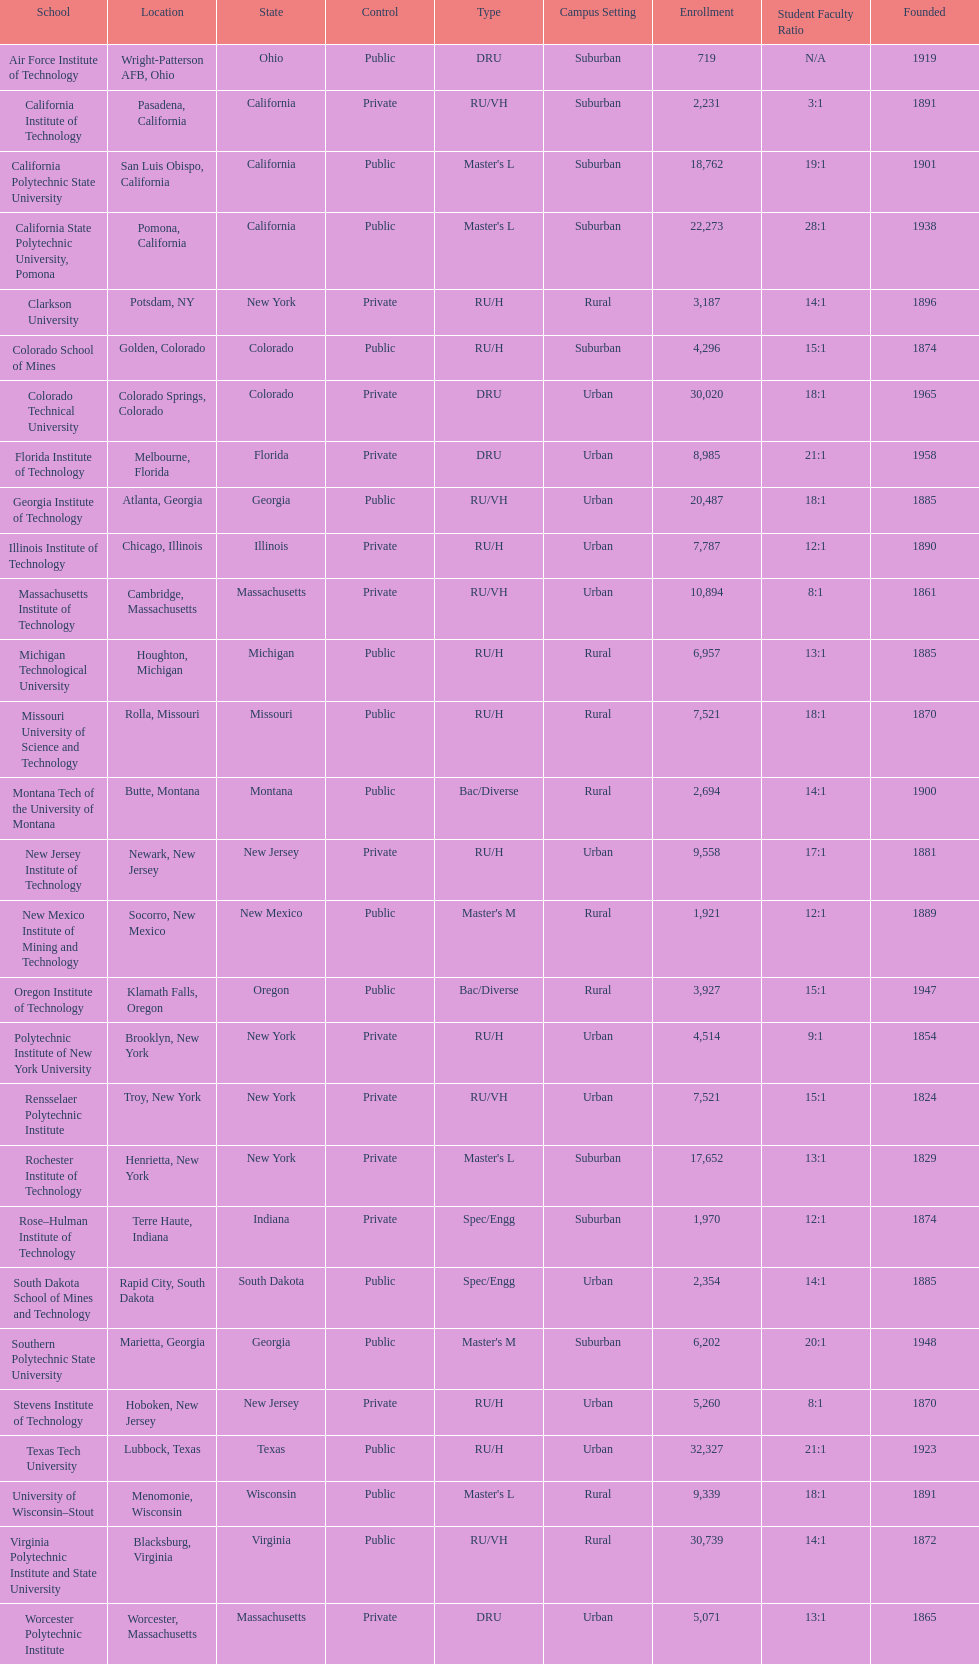What's the number of schools represented in the table? 28. 